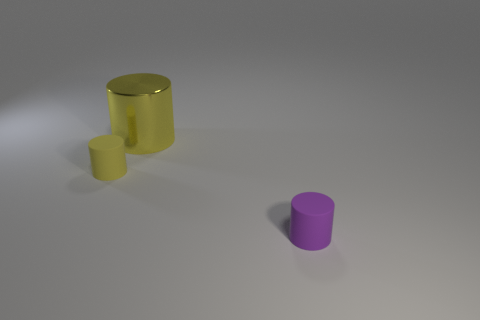Subtract all small purple cylinders. How many cylinders are left? 2 Add 2 small yellow matte objects. How many objects exist? 5 Subtract all yellow rubber cylinders. Subtract all yellow cylinders. How many objects are left? 0 Add 3 big yellow metal cylinders. How many big yellow metal cylinders are left? 4 Add 1 large shiny cylinders. How many large shiny cylinders exist? 2 Subtract 0 blue balls. How many objects are left? 3 